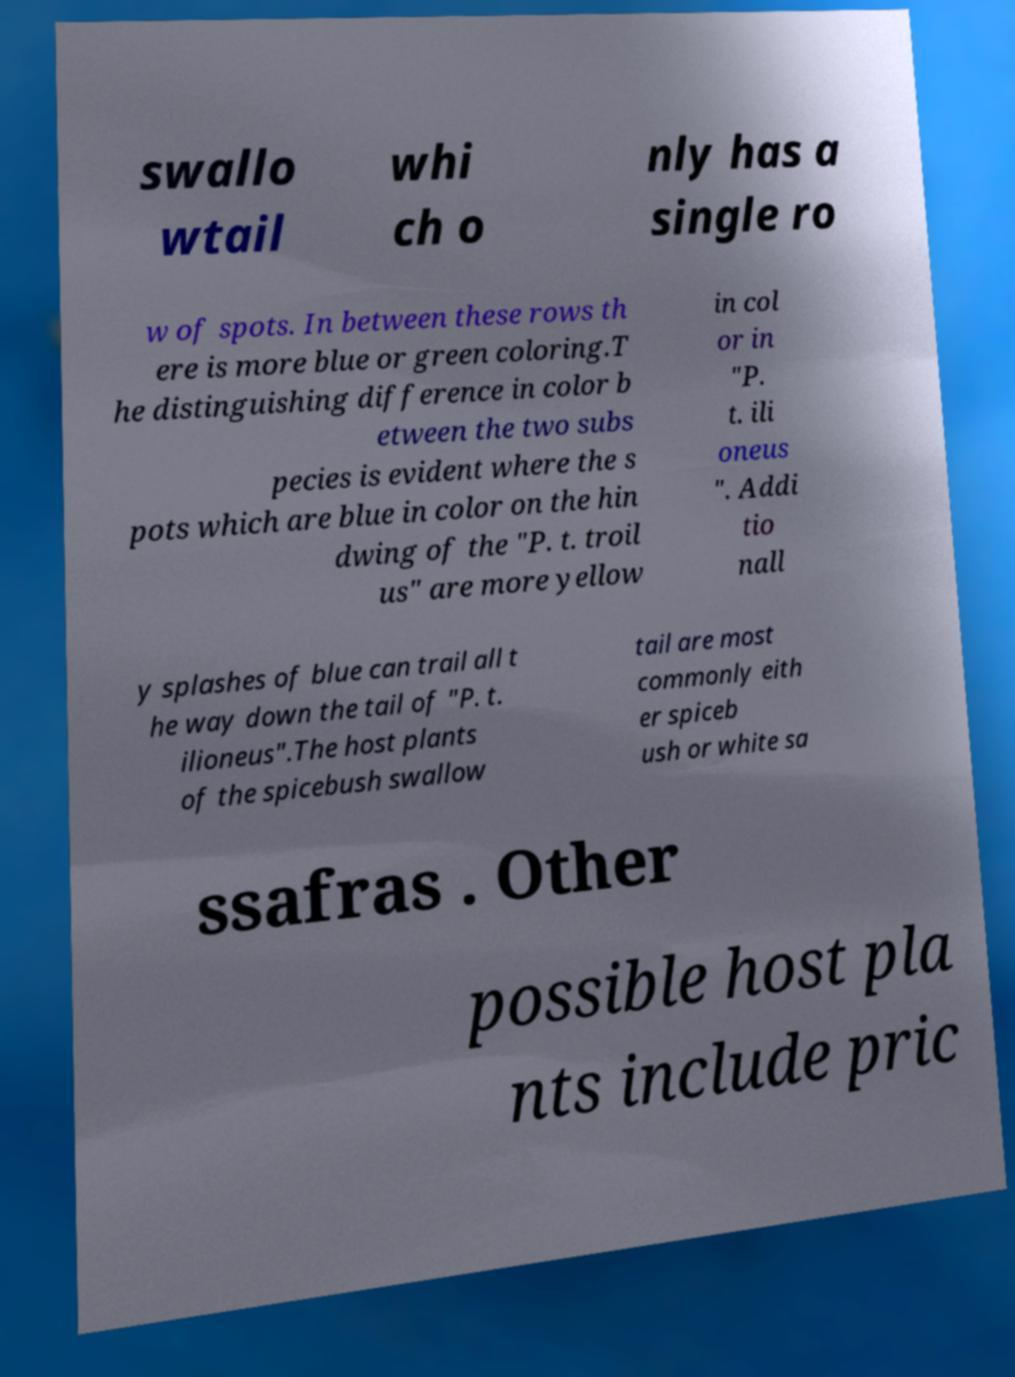Please identify and transcribe the text found in this image. swallo wtail whi ch o nly has a single ro w of spots. In between these rows th ere is more blue or green coloring.T he distinguishing difference in color b etween the two subs pecies is evident where the s pots which are blue in color on the hin dwing of the "P. t. troil us" are more yellow in col or in "P. t. ili oneus ". Addi tio nall y splashes of blue can trail all t he way down the tail of "P. t. ilioneus".The host plants of the spicebush swallow tail are most commonly eith er spiceb ush or white sa ssafras . Other possible host pla nts include pric 